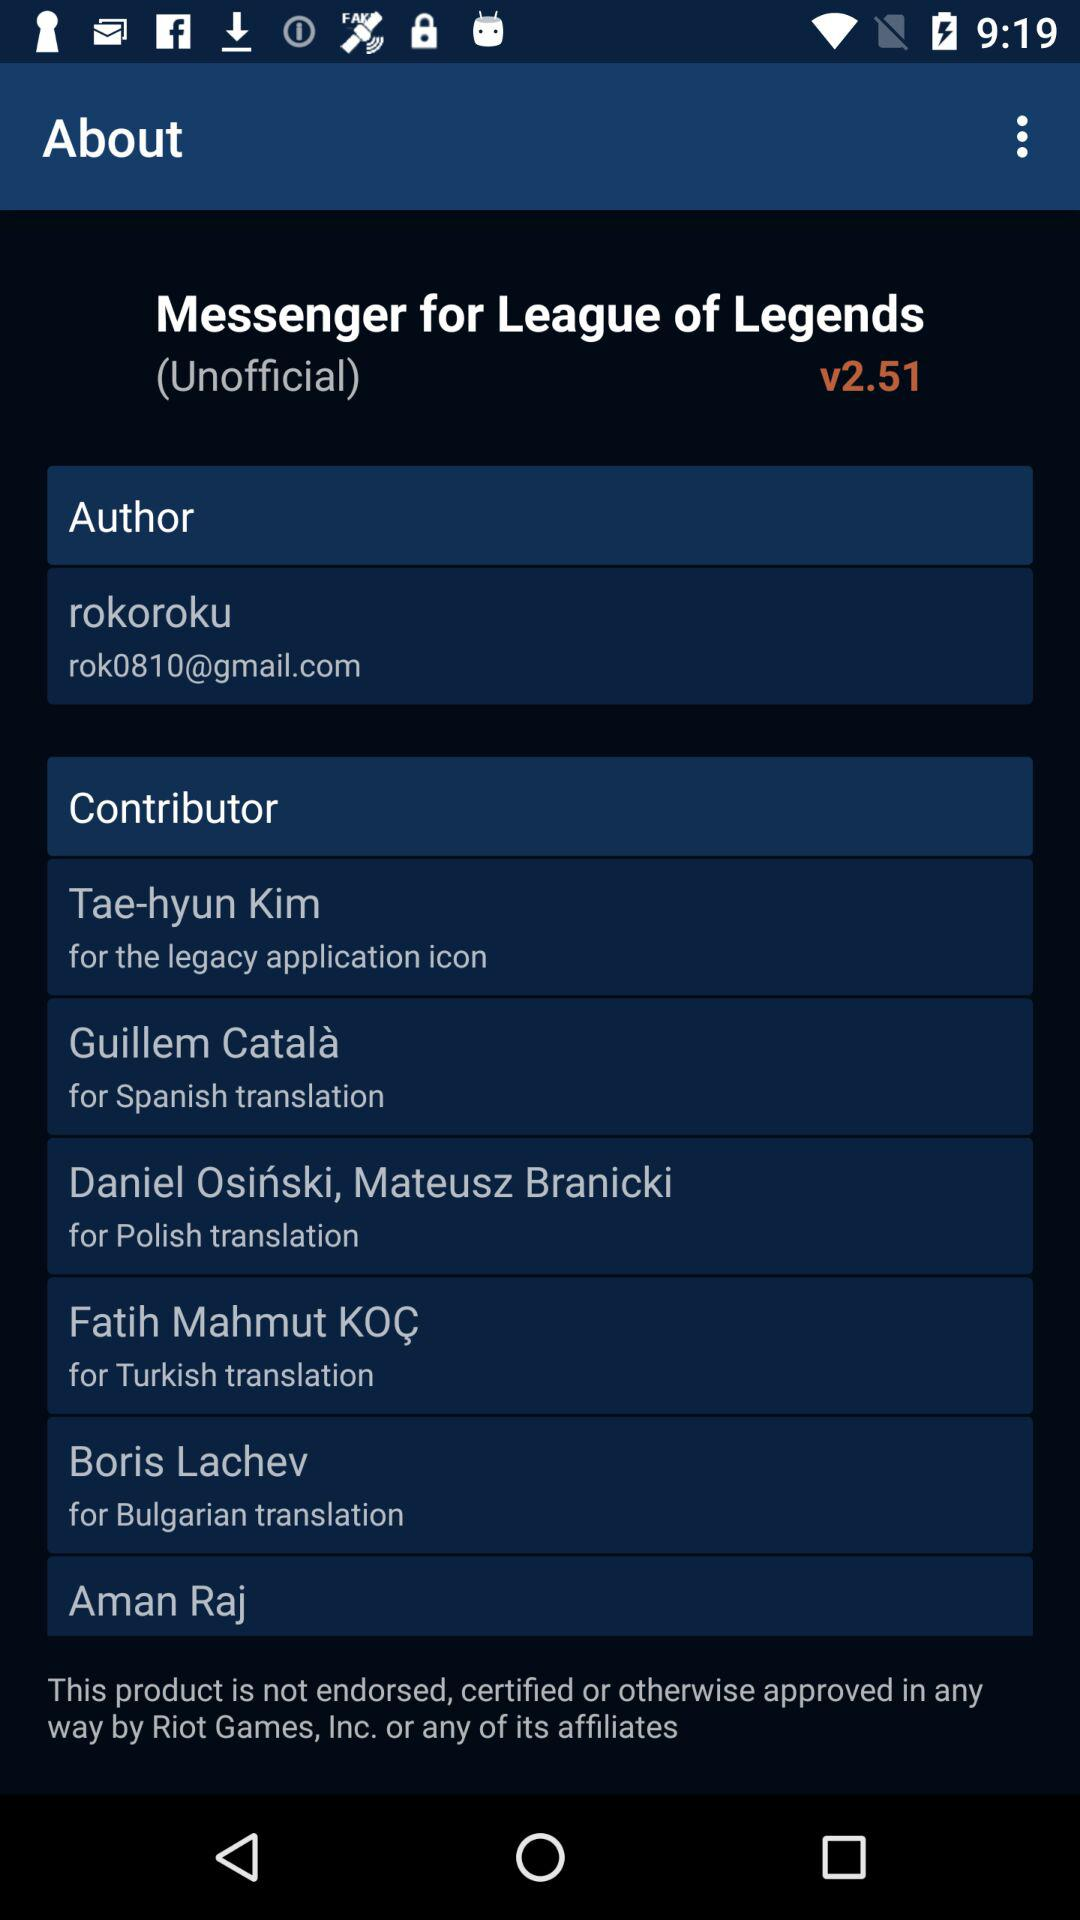What is the name of the application? The application name is "League of Legends". 